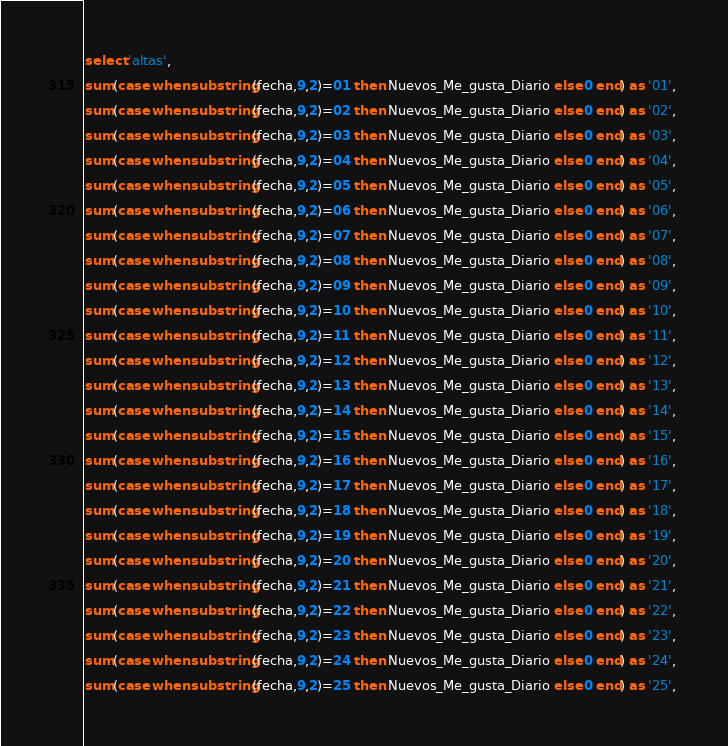<code> <loc_0><loc_0><loc_500><loc_500><_SQL_>select 'altas', 
sum(case when substring(fecha,9,2)=01 then Nuevos_Me_gusta_Diario else 0 end) as '01', 
sum(case when substring(fecha,9,2)=02 then Nuevos_Me_gusta_Diario else 0 end) as '02', 
sum(case when substring(fecha,9,2)=03 then Nuevos_Me_gusta_Diario else 0 end) as '03', 
sum(case when substring(fecha,9,2)=04 then Nuevos_Me_gusta_Diario else 0 end) as '04', 
sum(case when substring(fecha,9,2)=05 then Nuevos_Me_gusta_Diario else 0 end) as '05', 
sum(case when substring(fecha,9,2)=06 then Nuevos_Me_gusta_Diario else 0 end) as '06', 
sum(case when substring(fecha,9,2)=07 then Nuevos_Me_gusta_Diario else 0 end) as '07', 
sum(case when substring(fecha,9,2)=08 then Nuevos_Me_gusta_Diario else 0 end) as '08', 
sum(case when substring(fecha,9,2)=09 then Nuevos_Me_gusta_Diario else 0 end) as '09', 
sum(case when substring(fecha,9,2)=10 then Nuevos_Me_gusta_Diario else 0 end) as '10', 
sum(case when substring(fecha,9,2)=11 then Nuevos_Me_gusta_Diario else 0 end) as '11', 
sum(case when substring(fecha,9,2)=12 then Nuevos_Me_gusta_Diario else 0 end) as '12', 
sum(case when substring(fecha,9,2)=13 then Nuevos_Me_gusta_Diario else 0 end) as '13', 
sum(case when substring(fecha,9,2)=14 then Nuevos_Me_gusta_Diario else 0 end) as '14', 
sum(case when substring(fecha,9,2)=15 then Nuevos_Me_gusta_Diario else 0 end) as '15', 
sum(case when substring(fecha,9,2)=16 then Nuevos_Me_gusta_Diario else 0 end) as '16', 
sum(case when substring(fecha,9,2)=17 then Nuevos_Me_gusta_Diario else 0 end) as '17', 
sum(case when substring(fecha,9,2)=18 then Nuevos_Me_gusta_Diario else 0 end) as '18', 
sum(case when substring(fecha,9,2)=19 then Nuevos_Me_gusta_Diario else 0 end) as '19', 
sum(case when substring(fecha,9,2)=20 then Nuevos_Me_gusta_Diario else 0 end) as '20', 
sum(case when substring(fecha,9,2)=21 then Nuevos_Me_gusta_Diario else 0 end) as '21', 
sum(case when substring(fecha,9,2)=22 then Nuevos_Me_gusta_Diario else 0 end) as '22', 
sum(case when substring(fecha,9,2)=23 then Nuevos_Me_gusta_Diario else 0 end) as '23', 
sum(case when substring(fecha,9,2)=24 then Nuevos_Me_gusta_Diario else 0 end) as '24', 
sum(case when substring(fecha,9,2)=25 then Nuevos_Me_gusta_Diario else 0 end) as '25', </code> 